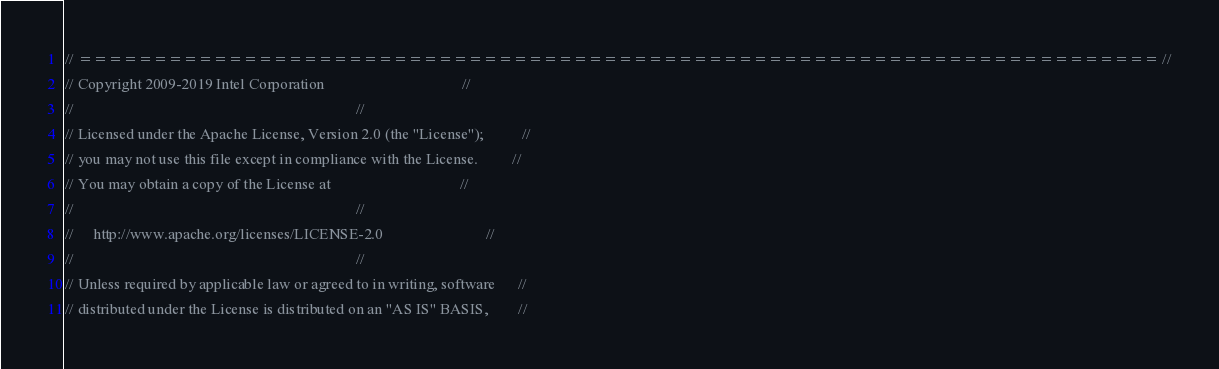<code> <loc_0><loc_0><loc_500><loc_500><_C++_>// ======================================================================== //
// Copyright 2009-2019 Intel Corporation                                    //
//                                                                          //
// Licensed under the Apache License, Version 2.0 (the "License");          //
// you may not use this file except in compliance with the License.         //
// You may obtain a copy of the License at                                  //
//                                                                          //
//     http://www.apache.org/licenses/LICENSE-2.0                           //
//                                                                          //
// Unless required by applicable law or agreed to in writing, software      //
// distributed under the License is distributed on an "AS IS" BASIS,        //</code> 